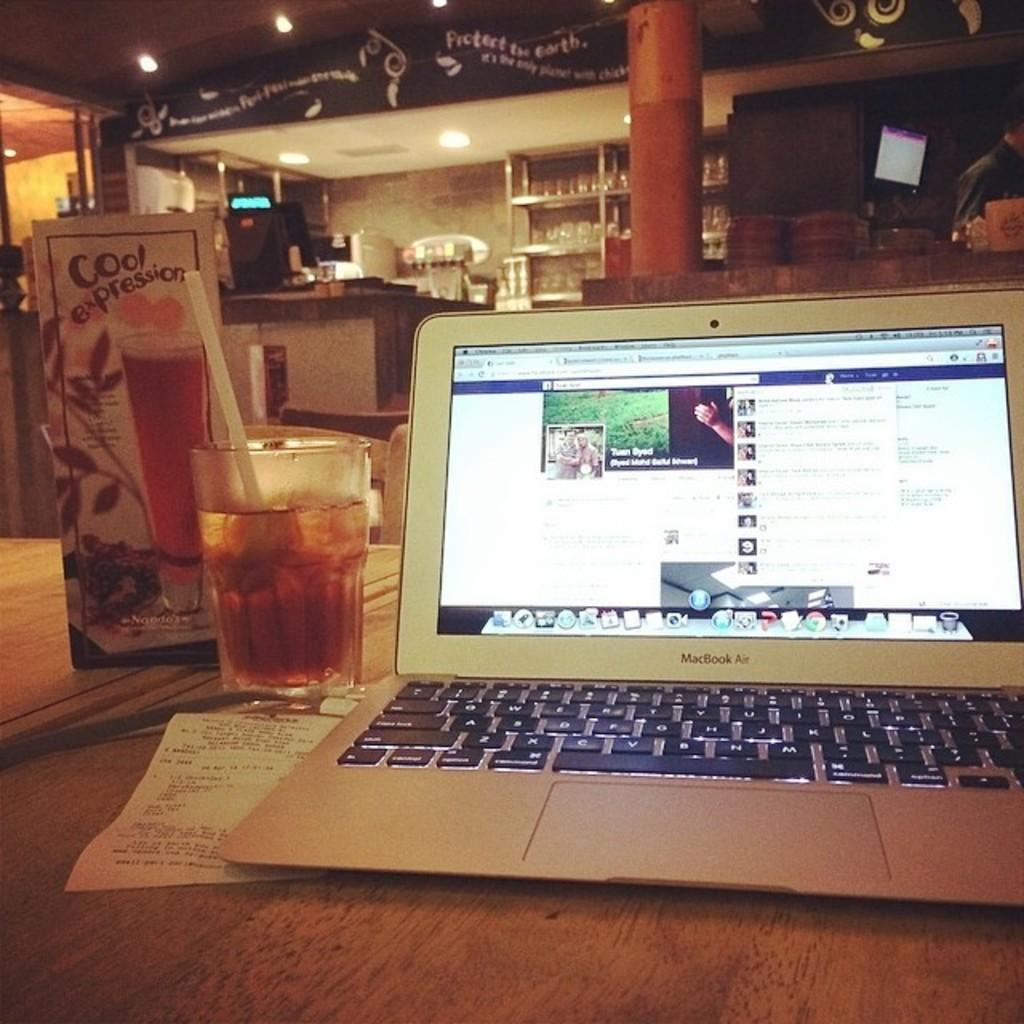What electronic device is visible in the image? There is a laptop in the image. What is in the glass that is visible in the image? There is a glass with a straw in it in the image. What is on the table in the image? There is a piece of paper on a table in the image. What can be seen in the background of the image? There is a shelf, lights on the ceiling, and a roof visible in the background of the image. What type of truck is parked outside the building in the image? There is no truck visible in the image; only a laptop, a glass with a straw, a piece of paper on a table, and various elements in the background are present. 